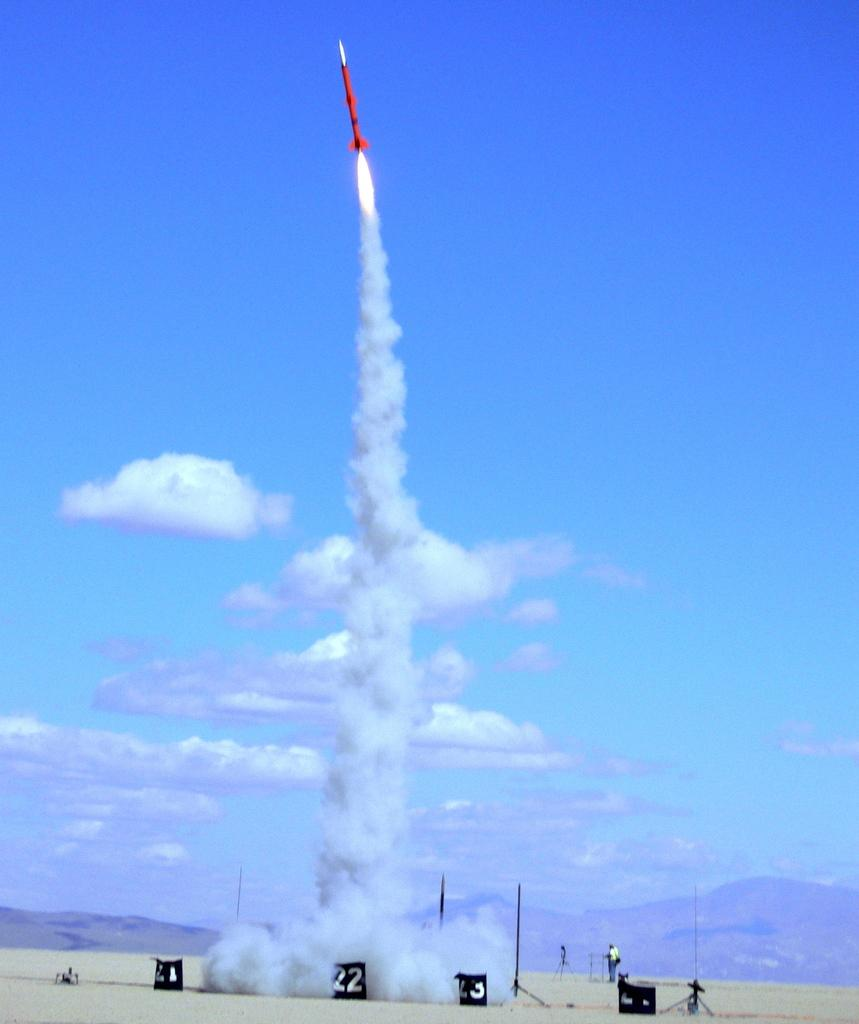What is the main subject of the image? There is a rocket launching into the sky in the image. What else can be seen on the ground in the image? There are boxes on the land in the image. Can you describe the background of the image? There is a man standing in the background of the image, and the sky is visible with clouds. How many icicles are hanging from the rocket in the image? There are no icicles present in the image; it features a rocket launching into the sky with clouds in the background. 